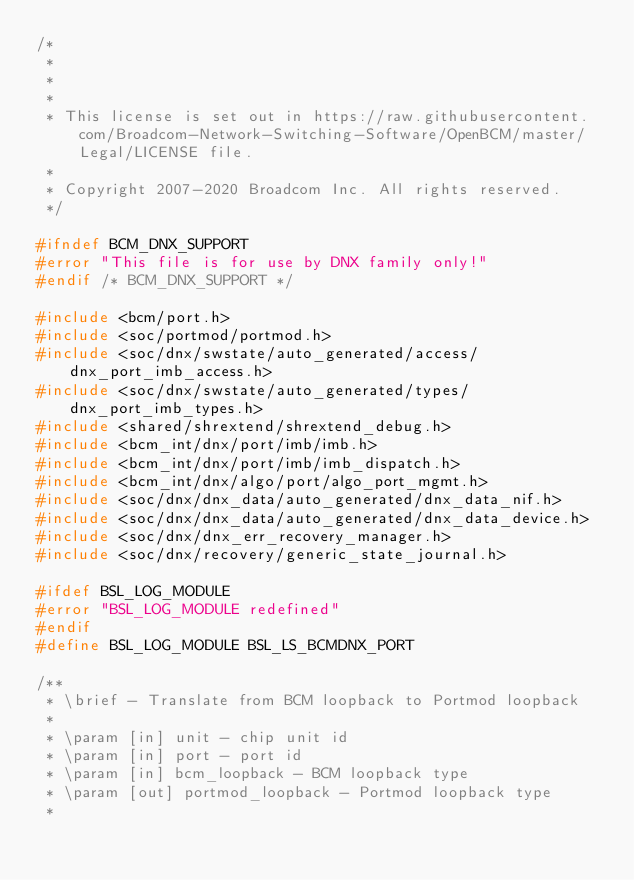Convert code to text. <code><loc_0><loc_0><loc_500><loc_500><_C_>/*
 *         
 * 
 * 
 * This license is set out in https://raw.githubusercontent.com/Broadcom-Network-Switching-Software/OpenBCM/master/Legal/LICENSE file.
 * 
 * Copyright 2007-2020 Broadcom Inc. All rights reserved.
 */

#ifndef BCM_DNX_SUPPORT
#error "This file is for use by DNX family only!"
#endif /* BCM_DNX_SUPPORT */

#include <bcm/port.h>
#include <soc/portmod/portmod.h>
#include <soc/dnx/swstate/auto_generated/access/dnx_port_imb_access.h>
#include <soc/dnx/swstate/auto_generated/types/dnx_port_imb_types.h>
#include <shared/shrextend/shrextend_debug.h>
#include <bcm_int/dnx/port/imb/imb.h>
#include <bcm_int/dnx/port/imb/imb_dispatch.h>
#include <bcm_int/dnx/algo/port/algo_port_mgmt.h>
#include <soc/dnx/dnx_data/auto_generated/dnx_data_nif.h>
#include <soc/dnx/dnx_data/auto_generated/dnx_data_device.h>
#include <soc/dnx/dnx_err_recovery_manager.h>
#include <soc/dnx/recovery/generic_state_journal.h>

#ifdef BSL_LOG_MODULE
#error "BSL_LOG_MODULE redefined"
#endif
#define BSL_LOG_MODULE BSL_LS_BCMDNX_PORT

/**
 * \brief - Translate from BCM loopback to Portmod loopback
 * 
 * \param [in] unit - chip unit id
 * \param [in] port - port id
 * \param [in] bcm_loopback - BCM loopback type
 * \param [out] portmod_loopback - Portmod loopback type
 *   </code> 